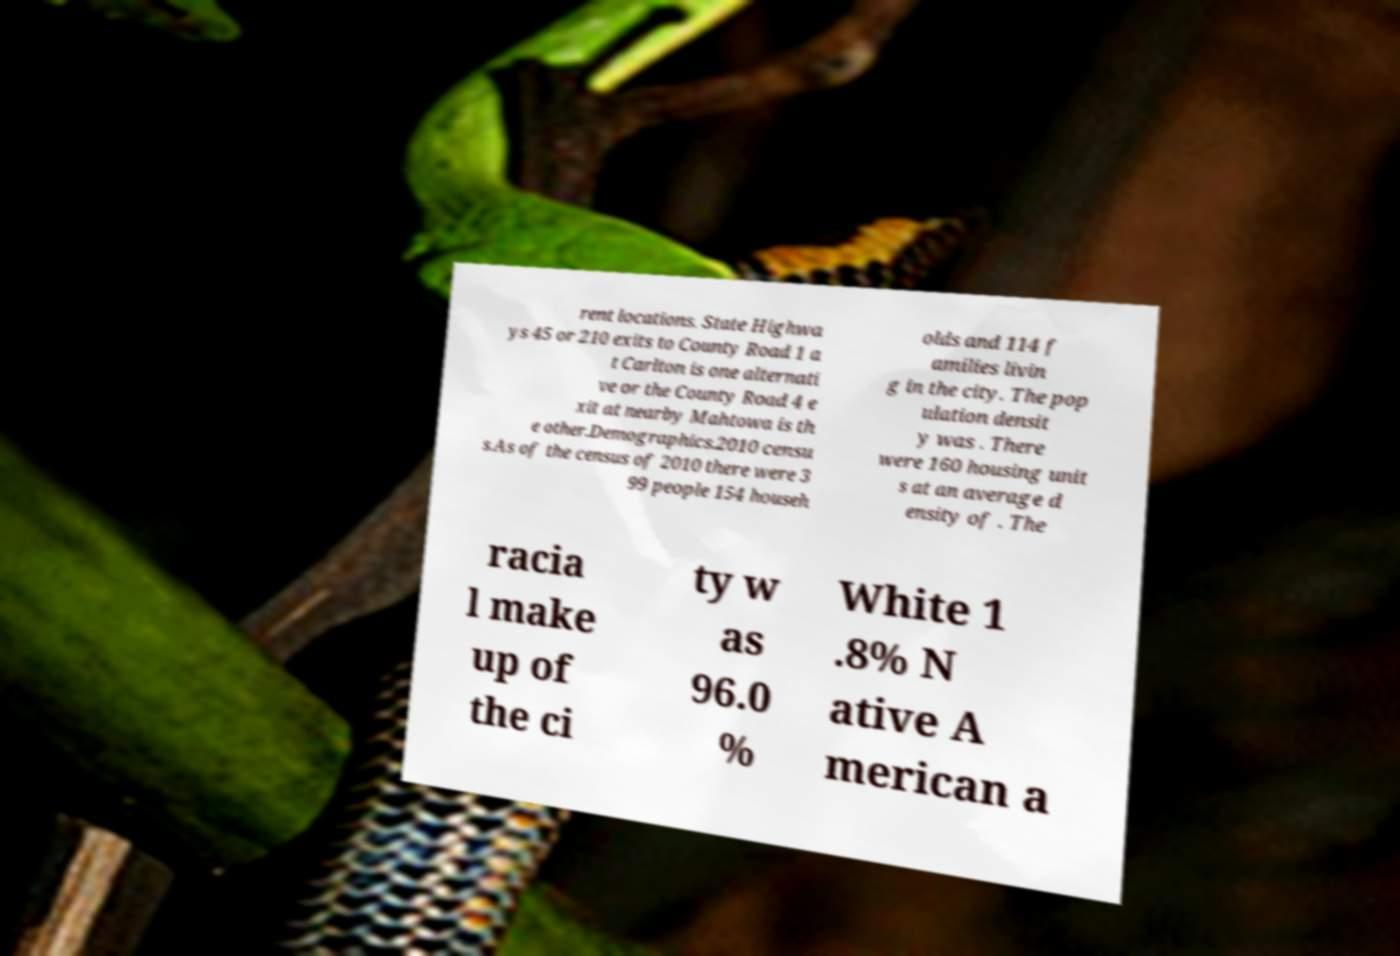Please identify and transcribe the text found in this image. rent locations. State Highwa ys 45 or 210 exits to County Road 1 a t Carlton is one alternati ve or the County Road 4 e xit at nearby Mahtowa is th e other.Demographics.2010 censu s.As of the census of 2010 there were 3 99 people 154 househ olds and 114 f amilies livin g in the city. The pop ulation densit y was . There were 160 housing unit s at an average d ensity of . The racia l make up of the ci ty w as 96.0 % White 1 .8% N ative A merican a 